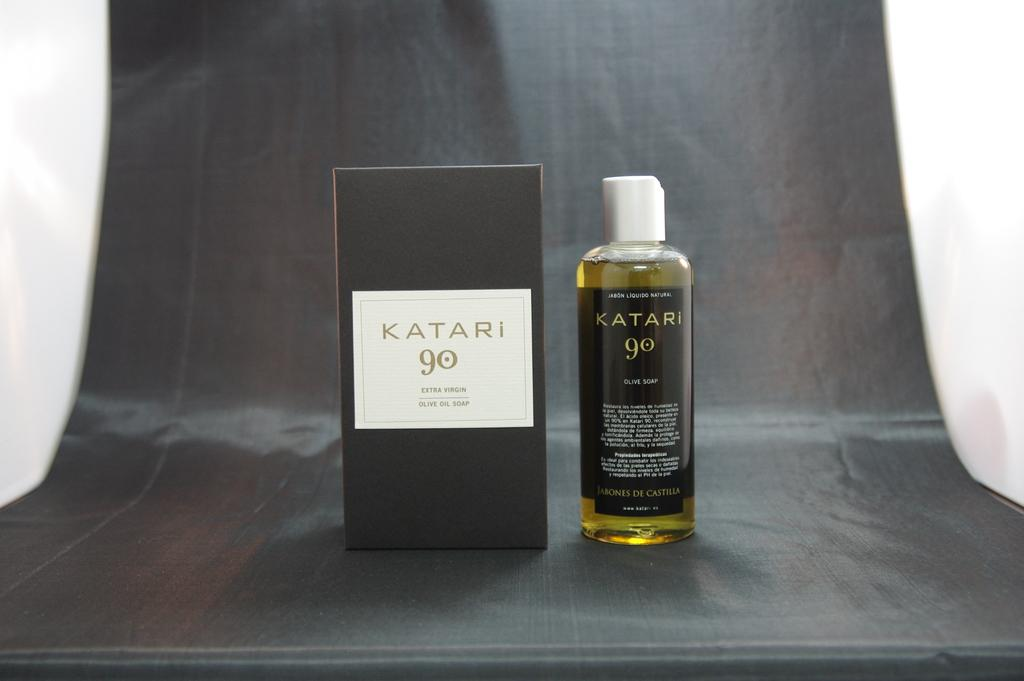What is the color of the box in the image? The box in the image is black. What can be said about the bottle in the image? The bottle in the image has a yellow and black color label. What type of window treatment is visible in the image? There is a black color curtain in the image. How much lumber is stacked behind the black color box in the image? There is no lumber visible in the image; it only features a black color box, a bottle with a yellow and black color label, and a black color curtain. 